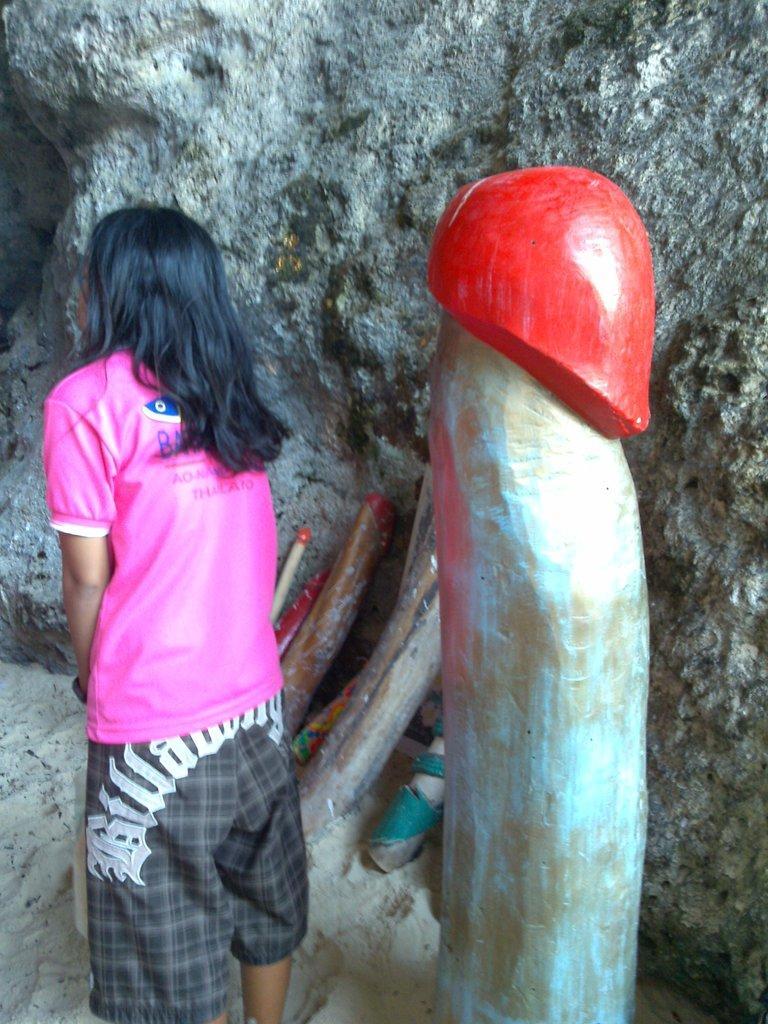Could you give a brief overview of what you see in this image? In this image in the front there is a woman standing. On the right side there is a wooden log. In the background there is a wall. 